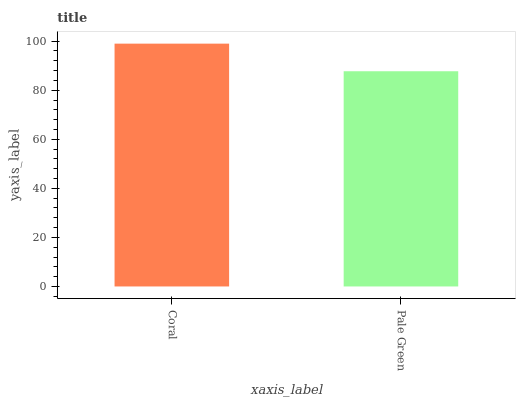Is Pale Green the minimum?
Answer yes or no. Yes. Is Coral the maximum?
Answer yes or no. Yes. Is Pale Green the maximum?
Answer yes or no. No. Is Coral greater than Pale Green?
Answer yes or no. Yes. Is Pale Green less than Coral?
Answer yes or no. Yes. Is Pale Green greater than Coral?
Answer yes or no. No. Is Coral less than Pale Green?
Answer yes or no. No. Is Coral the high median?
Answer yes or no. Yes. Is Pale Green the low median?
Answer yes or no. Yes. Is Pale Green the high median?
Answer yes or no. No. Is Coral the low median?
Answer yes or no. No. 